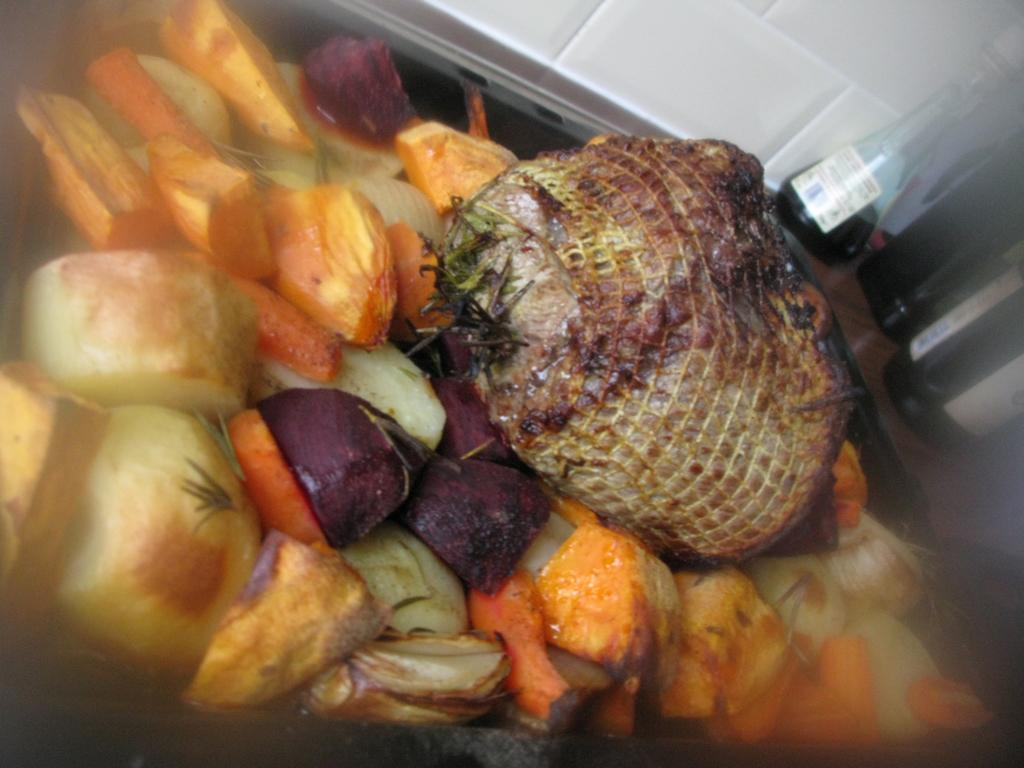What type of dish is featured in the image? There is a salad in the image. What is one specific ingredient in the salad? The salad contains beetroot. What can be inferred about the salad from the facts? The salad contains many veggies and is in a bowl. What else is present on the table with the salad? There are bottles beside the salad on a table. What is located in front of the table? There is a wall in front of the table. Can you see any fish swimming in the salad? No, there are no fish present in the salad or the image. What type of farm is visible in the image? There is no farm visible in the image; it features a salad on a table with bottles and a wall in front of it. 